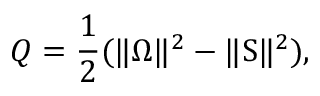<formula> <loc_0><loc_0><loc_500><loc_500>Q = \frac { 1 } { 2 } ( \| \Omega \| ^ { 2 } - \| S \| ^ { 2 } ) ,</formula> 